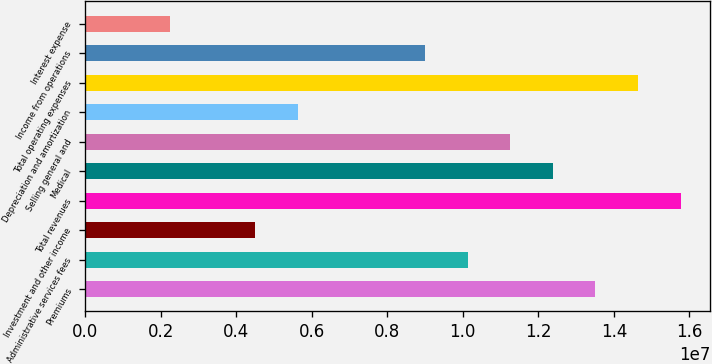Convert chart to OTSL. <chart><loc_0><loc_0><loc_500><loc_500><bar_chart><fcel>Premiums<fcel>Administrative services fees<fcel>Investment and other income<fcel>Total revenues<fcel>Medical<fcel>Selling general and<fcel>Depreciation and amortization<fcel>Total operating expenses<fcel>Income from operations<fcel>Interest expense<nl><fcel>1.35134e+07<fcel>1.01351e+07<fcel>4.50447e+06<fcel>1.57657e+07<fcel>1.23873e+07<fcel>1.12612e+07<fcel>5.63059e+06<fcel>1.46395e+07<fcel>9.00894e+06<fcel>2.25224e+06<nl></chart> 